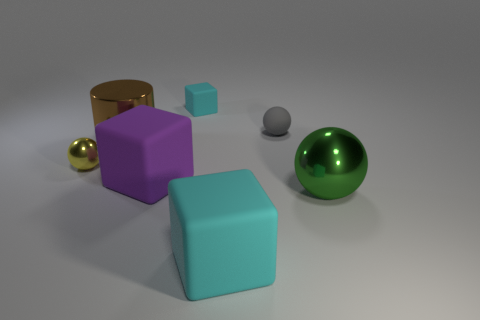Subtract all big matte cubes. How many cubes are left? 1 Subtract all green cylinders. How many cyan cubes are left? 2 Subtract all green balls. How many balls are left? 2 Subtract 1 blocks. How many blocks are left? 2 Add 2 tiny brown metallic cylinders. How many objects exist? 9 Subtract all balls. How many objects are left? 4 Subtract all green cubes. Subtract all blue cylinders. How many cubes are left? 3 Add 4 big cylinders. How many big cylinders exist? 5 Subtract 2 cyan blocks. How many objects are left? 5 Subtract all big green matte spheres. Subtract all tiny blocks. How many objects are left? 6 